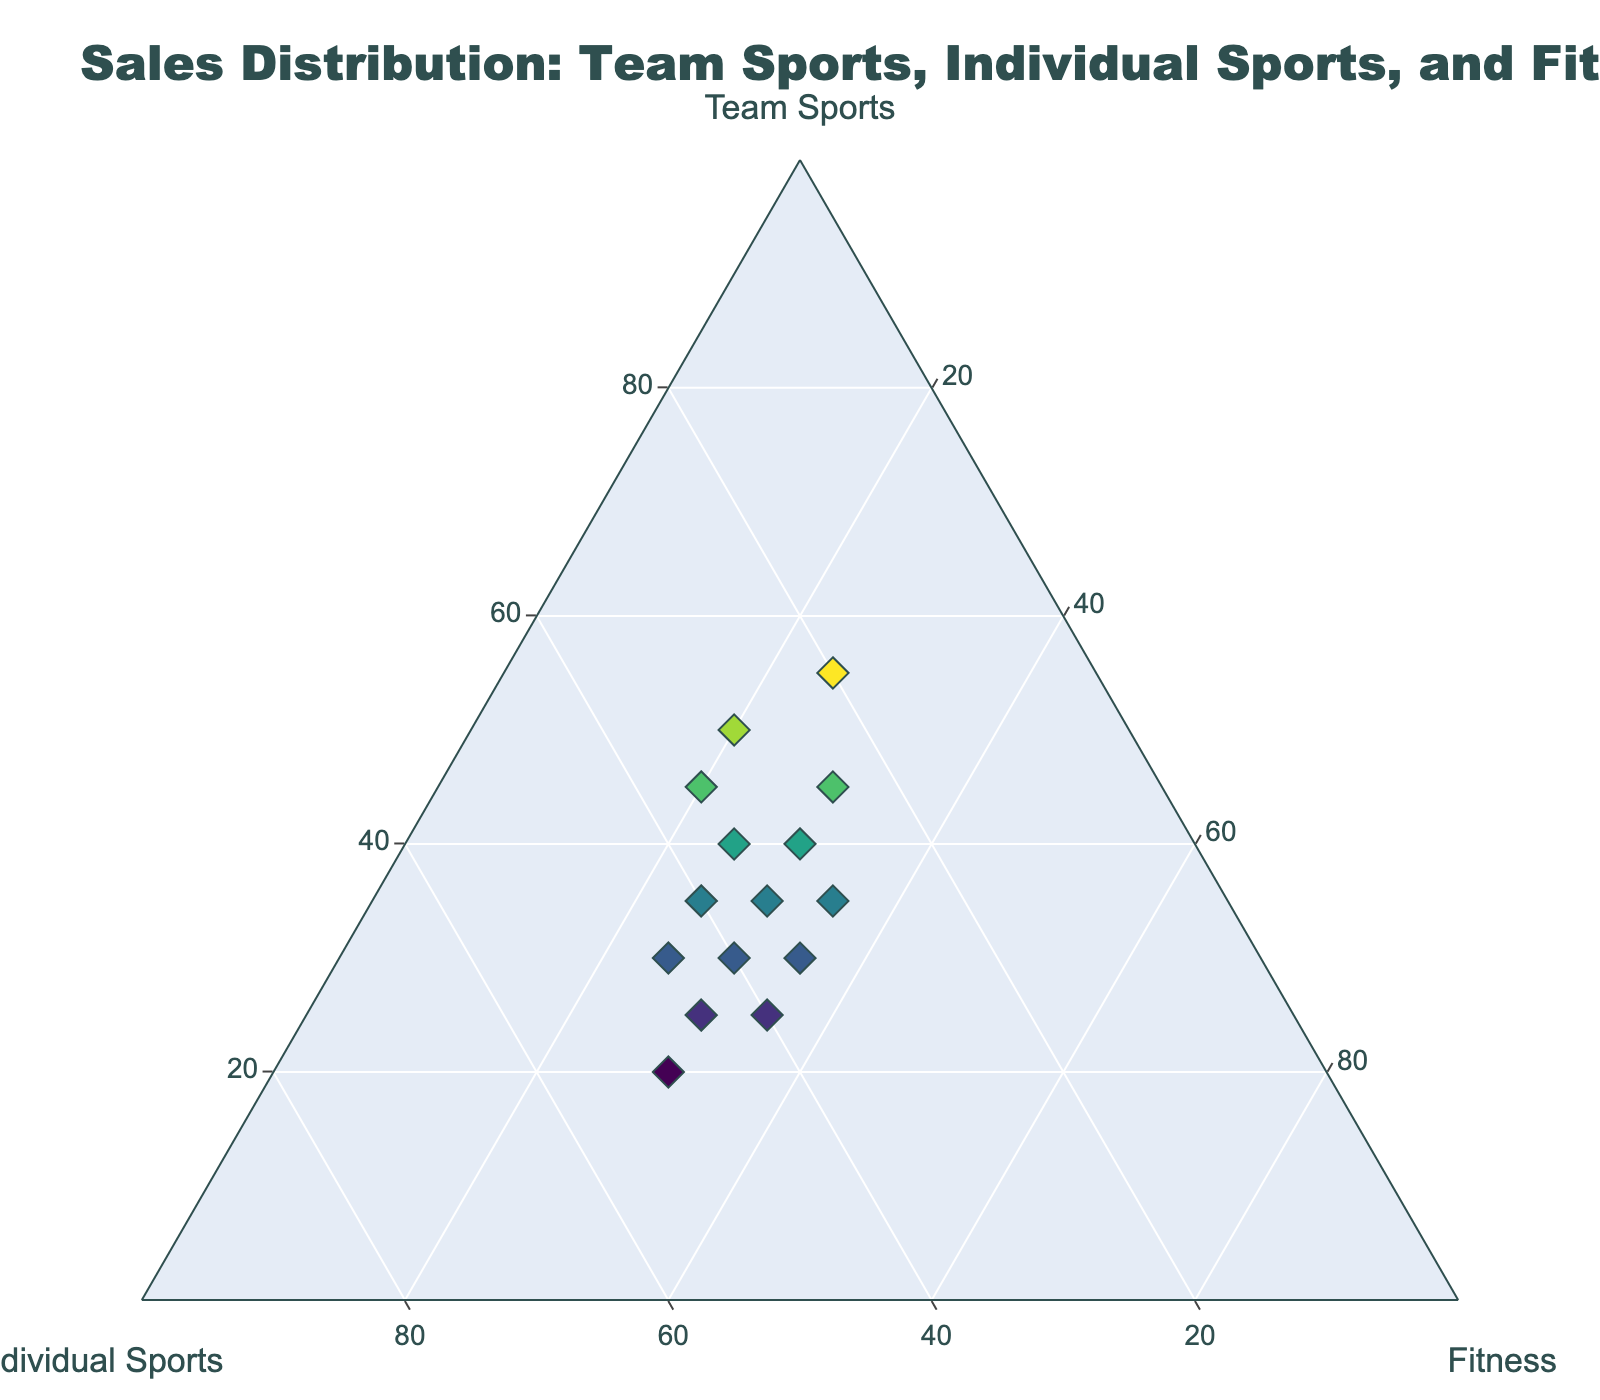What is the title of the plot? The title is displayed at the top of the plot and gives an overview of what the plot is about.
Answer: Sales Distribution: Team Sports, Individual Sports, and Fitness How many data points are there in the plot? Each marker on the plot represents a data point. Count the markers to determine the number of data points.
Answer: 15 Which category is represented on the left axis? The axis labels specify which categories are represented on each side of the ternary plot. The left axis label will indicate the corresponding category.
Answer: Individual Sports Which data point has the highest percentage for Team Sports? Examine the markers with the highest values along the Team Sports axis, located at the bottom of the plot.
Answer: 55% What is the average percentage of Fitness across all points? Sum the percentages for Fitness (25 + 25 + 35 + 30 + 35 + 20 + 30 + 35 + 25 + 25 + 30 + 30 + 20 + 30 + 30) and divide by the total number of points (15).
Answer: 28.67% Between Team Sports and Individual Sports, which category generally has a higher percentage? Observe the distribution of data points and their proximity to to each axis's extremes to judge the general trend.
Answer: Individual Sports Which data point shows an equal distribution across all three categories? Look for a data point where the percentages for Team Sports, Individual Sports, and Fitness are roughly the same.
Answer: 35, 35, 30 How many data points show a higher percentage in Fitness than in Team Sports? Compare the values of the Fitness and Team Sports percentages for each data point and count those with Fitness > Team Sports.
Answer: 3 What is the sum of the Individual Sports percentage for data points where Team Sports percentage is above 40%? Identify the points where Team Sports is greater than 40%, then sum their Individual Sports percentages (25 + 35 + 30 + 20 + 30).
Answer: 140 Which category has the most variation in its sales percentage? Look at the spread of data points along each axis to see which category has the widest range of values.
Answer: Team Sports 